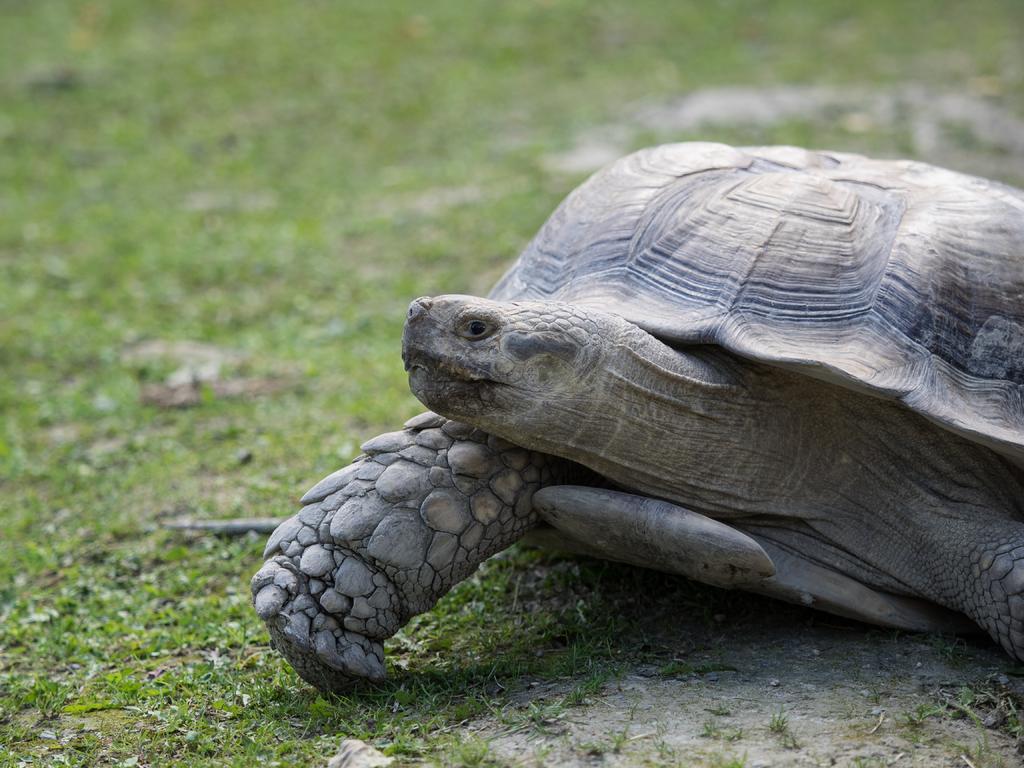In one or two sentences, can you explain what this image depicts? In the foreground of this picture, there is a tortoise on the right side of the image and the background there is the grass. 